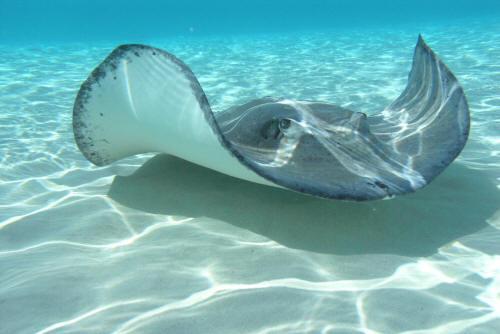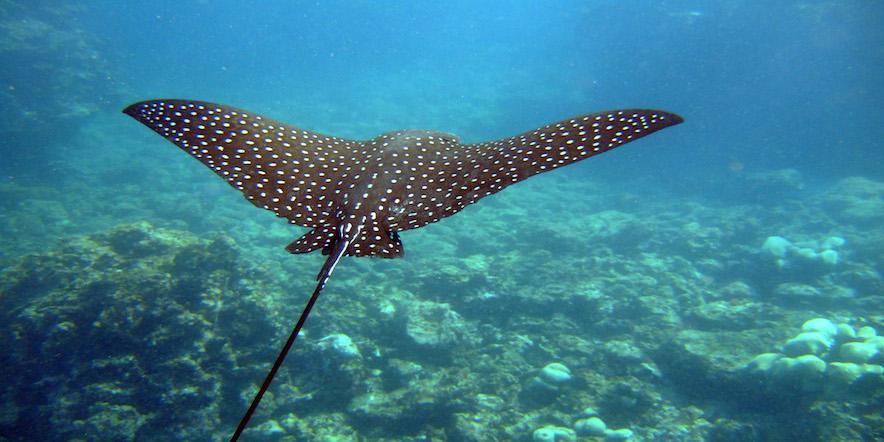The first image is the image on the left, the second image is the image on the right. For the images displayed, is the sentence "Each image has exactly one ray." factually correct? Answer yes or no. Yes. 